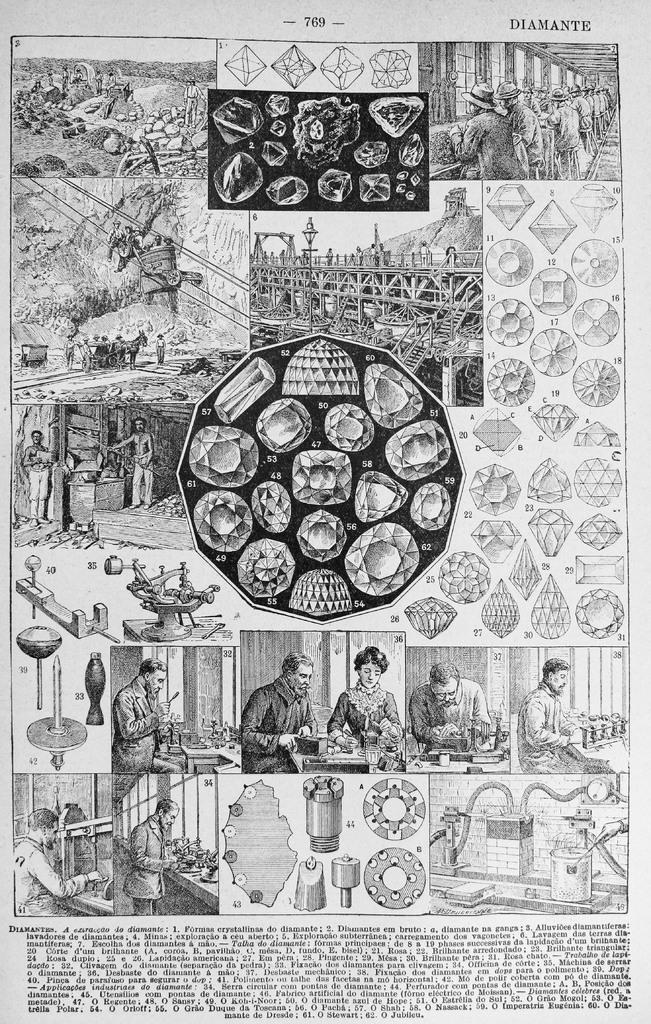How would you summarize this image in a sentence or two? In this picture, we can see a poster with some text, and some images on it. 